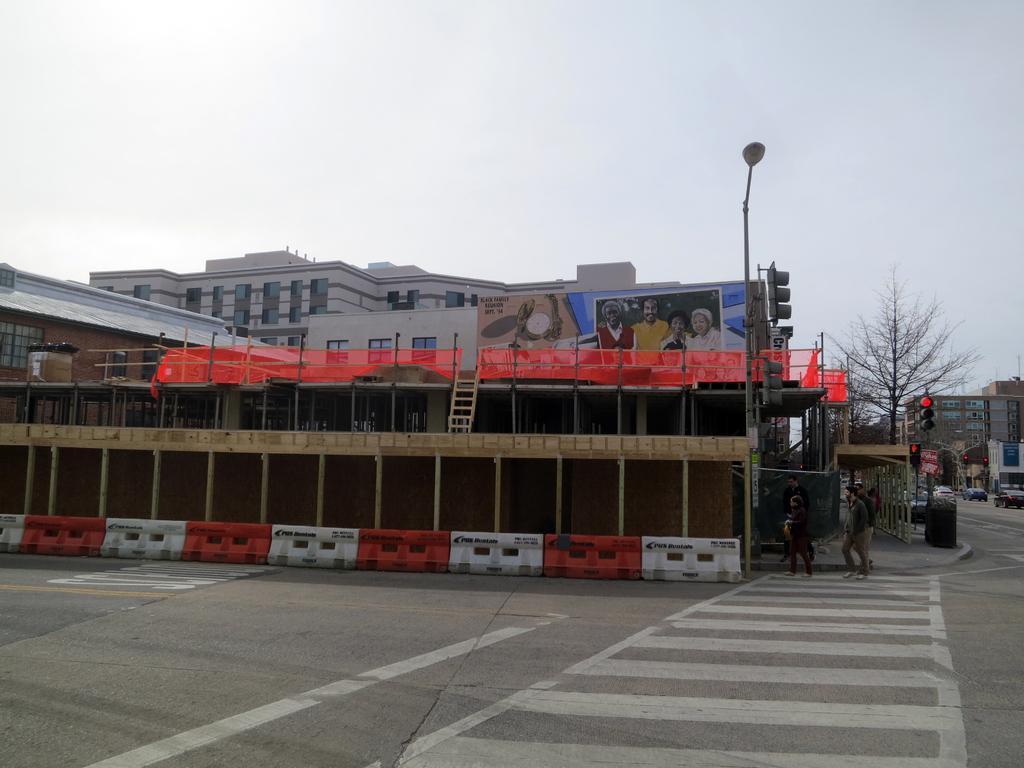How would you summarize this image in a sentence or two? In this image there is the sky truncated towards the top of the image, there are buildings truncated towards the left of the image, there are boards, there is text on the board, there are poles, there are traffic lights, there is a street light, there is road truncated towards the bottom of the image, there are persons walking on the road, there are vehicles on the road, there is a vehicle truncated towards the right of the image, there is a building truncated towards the right of the image, there is a tree, there are objects on the ground. 